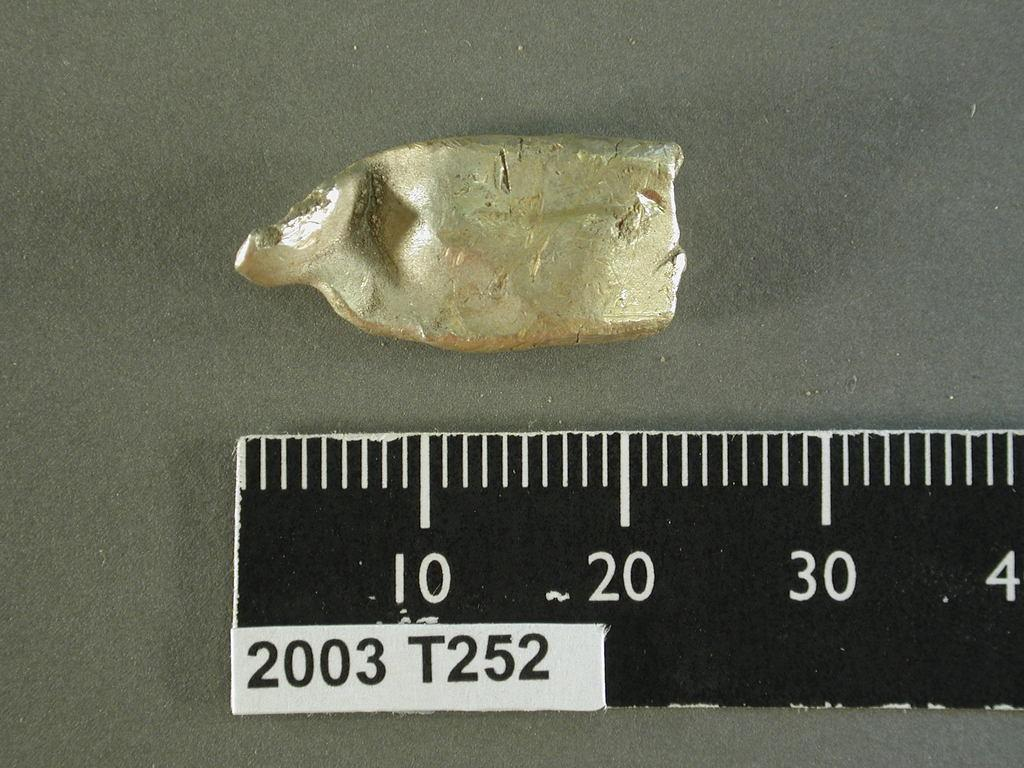Provide a one-sentence caption for the provided image. A piece of something being measured against a ruler that says  2003 T252. 